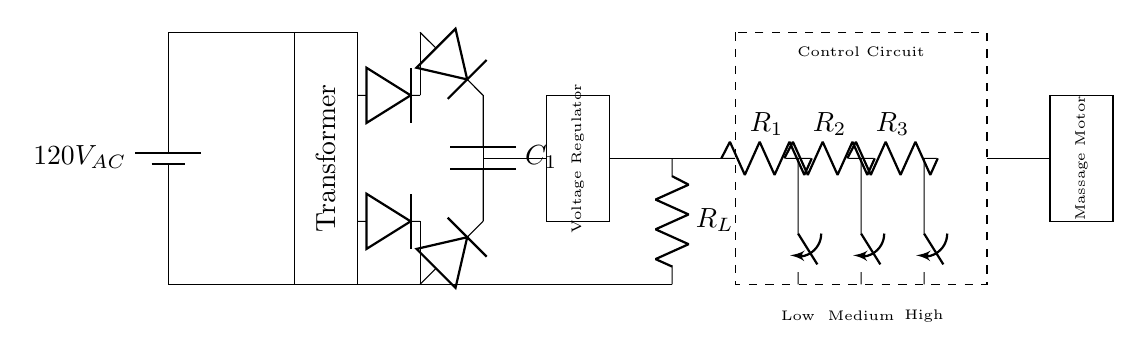What is the input voltage of the power supply? The input voltage is indicated on the circuit as 120V AC coming from the battery symbol at the top left.
Answer: 120V AC What component is responsible for converting AC to DC? The rectifier in the circuit performs this function, as it consists of diodes that allow current to flow in one direction, thus converting AC to DC.
Answer: Rectifier How many different massage settings does this chair have? The control circuit has three resistors indicating three settings: Low, Medium, and High, which are connected to switches to select the settings.
Answer: Three What is the role of the smoothing capacitor in the circuit? The smoothing capacitor (denoted as C1) helps to reduce voltage fluctuations after rectification, providing a more stable DC voltage to the rest of the circuit.
Answer: Smoothing voltage Which component regulates the output voltage in this circuit? The voltage regulator, which is located after the smoothing capacitor in the circuit, is responsible for maintaining a consistent output voltage for the massage chair's operations despite input variations.
Answer: Voltage regulator What type of motor is used to power the massage function? The component labeled as "Massage Motor" is specifically designed to provide the mechanical action needed for the massage function of the chair.
Answer: Massage Motor 